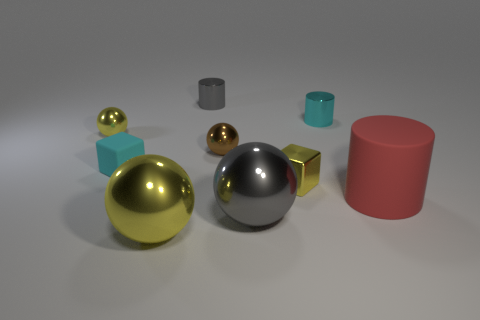Subtract all brown cubes. Subtract all gray cylinders. How many cubes are left? 2 Subtract all spheres. How many objects are left? 5 Add 7 gray matte cylinders. How many gray matte cylinders exist? 7 Subtract 0 blue cubes. How many objects are left? 9 Subtract all big cyan matte things. Subtract all gray things. How many objects are left? 7 Add 4 large yellow things. How many large yellow things are left? 5 